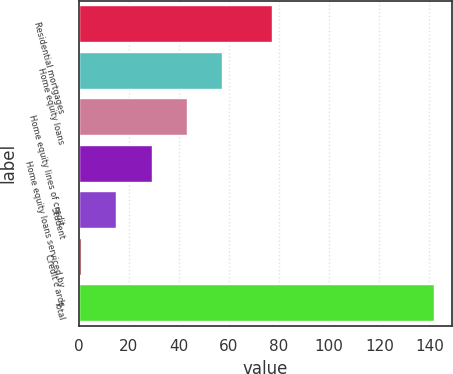<chart> <loc_0><loc_0><loc_500><loc_500><bar_chart><fcel>Residential mortgages<fcel>Home equity loans<fcel>Home equity lines of credit<fcel>Home equity loans serviced by<fcel>Student<fcel>Credit c ards<fcel>Total<nl><fcel>77<fcel>57.4<fcel>43.3<fcel>29.2<fcel>15.1<fcel>1<fcel>142<nl></chart> 